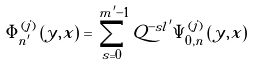<formula> <loc_0><loc_0><loc_500><loc_500>\Phi _ { n ^ { \prime } } ^ { \left ( j \right ) } \left ( y , x \right ) = \sum _ { s = 0 } ^ { m ^ { \prime } - 1 } Q ^ { - s l ^ { \prime } } \Psi _ { 0 , n } ^ { \left ( j \right ) } \left ( y , x \right )</formula> 